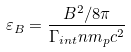Convert formula to latex. <formula><loc_0><loc_0><loc_500><loc_500>\varepsilon _ { B } = \frac { B ^ { 2 } / 8 \pi } { \Gamma _ { i n t } n m _ { p } c ^ { 2 } }</formula> 